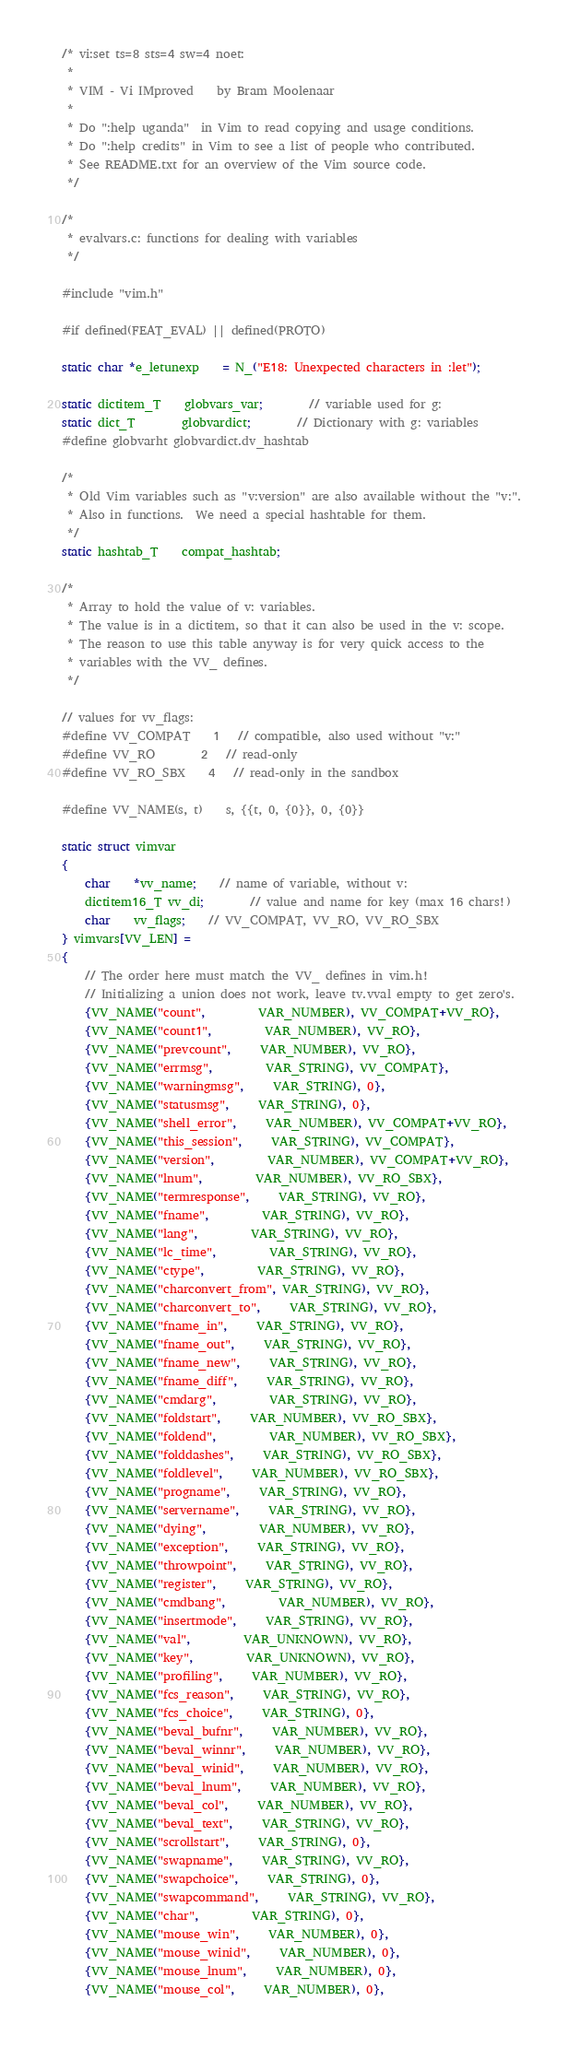Convert code to text. <code><loc_0><loc_0><loc_500><loc_500><_C_>/* vi:set ts=8 sts=4 sw=4 noet:
 *
 * VIM - Vi IMproved	by Bram Moolenaar
 *
 * Do ":help uganda"  in Vim to read copying and usage conditions.
 * Do ":help credits" in Vim to see a list of people who contributed.
 * See README.txt for an overview of the Vim source code.
 */

/*
 * evalvars.c: functions for dealing with variables
 */

#include "vim.h"

#if defined(FEAT_EVAL) || defined(PROTO)

static char *e_letunexp	= N_("E18: Unexpected characters in :let");

static dictitem_T	globvars_var;		// variable used for g:
static dict_T		globvardict;		// Dictionary with g: variables
#define globvarht globvardict.dv_hashtab

/*
 * Old Vim variables such as "v:version" are also available without the "v:".
 * Also in functions.  We need a special hashtable for them.
 */
static hashtab_T	compat_hashtab;

/*
 * Array to hold the value of v: variables.
 * The value is in a dictitem, so that it can also be used in the v: scope.
 * The reason to use this table anyway is for very quick access to the
 * variables with the VV_ defines.
 */

// values for vv_flags:
#define VV_COMPAT	1	// compatible, also used without "v:"
#define VV_RO		2	// read-only
#define VV_RO_SBX	4	// read-only in the sandbox

#define VV_NAME(s, t)	s, {{t, 0, {0}}, 0, {0}}

static struct vimvar
{
    char	*vv_name;	// name of variable, without v:
    dictitem16_T vv_di;		// value and name for key (max 16 chars!)
    char	vv_flags;	// VV_COMPAT, VV_RO, VV_RO_SBX
} vimvars[VV_LEN] =
{
    // The order here must match the VV_ defines in vim.h!
    // Initializing a union does not work, leave tv.vval empty to get zero's.
    {VV_NAME("count",		 VAR_NUMBER), VV_COMPAT+VV_RO},
    {VV_NAME("count1",		 VAR_NUMBER), VV_RO},
    {VV_NAME("prevcount",	 VAR_NUMBER), VV_RO},
    {VV_NAME("errmsg",		 VAR_STRING), VV_COMPAT},
    {VV_NAME("warningmsg",	 VAR_STRING), 0},
    {VV_NAME("statusmsg",	 VAR_STRING), 0},
    {VV_NAME("shell_error",	 VAR_NUMBER), VV_COMPAT+VV_RO},
    {VV_NAME("this_session",	 VAR_STRING), VV_COMPAT},
    {VV_NAME("version",		 VAR_NUMBER), VV_COMPAT+VV_RO},
    {VV_NAME("lnum",		 VAR_NUMBER), VV_RO_SBX},
    {VV_NAME("termresponse",	 VAR_STRING), VV_RO},
    {VV_NAME("fname",		 VAR_STRING), VV_RO},
    {VV_NAME("lang",		 VAR_STRING), VV_RO},
    {VV_NAME("lc_time",		 VAR_STRING), VV_RO},
    {VV_NAME("ctype",		 VAR_STRING), VV_RO},
    {VV_NAME("charconvert_from", VAR_STRING), VV_RO},
    {VV_NAME("charconvert_to",	 VAR_STRING), VV_RO},
    {VV_NAME("fname_in",	 VAR_STRING), VV_RO},
    {VV_NAME("fname_out",	 VAR_STRING), VV_RO},
    {VV_NAME("fname_new",	 VAR_STRING), VV_RO},
    {VV_NAME("fname_diff",	 VAR_STRING), VV_RO},
    {VV_NAME("cmdarg",		 VAR_STRING), VV_RO},
    {VV_NAME("foldstart",	 VAR_NUMBER), VV_RO_SBX},
    {VV_NAME("foldend",		 VAR_NUMBER), VV_RO_SBX},
    {VV_NAME("folddashes",	 VAR_STRING), VV_RO_SBX},
    {VV_NAME("foldlevel",	 VAR_NUMBER), VV_RO_SBX},
    {VV_NAME("progname",	 VAR_STRING), VV_RO},
    {VV_NAME("servername",	 VAR_STRING), VV_RO},
    {VV_NAME("dying",		 VAR_NUMBER), VV_RO},
    {VV_NAME("exception",	 VAR_STRING), VV_RO},
    {VV_NAME("throwpoint",	 VAR_STRING), VV_RO},
    {VV_NAME("register",	 VAR_STRING), VV_RO},
    {VV_NAME("cmdbang",		 VAR_NUMBER), VV_RO},
    {VV_NAME("insertmode",	 VAR_STRING), VV_RO},
    {VV_NAME("val",		 VAR_UNKNOWN), VV_RO},
    {VV_NAME("key",		 VAR_UNKNOWN), VV_RO},
    {VV_NAME("profiling",	 VAR_NUMBER), VV_RO},
    {VV_NAME("fcs_reason",	 VAR_STRING), VV_RO},
    {VV_NAME("fcs_choice",	 VAR_STRING), 0},
    {VV_NAME("beval_bufnr",	 VAR_NUMBER), VV_RO},
    {VV_NAME("beval_winnr",	 VAR_NUMBER), VV_RO},
    {VV_NAME("beval_winid",	 VAR_NUMBER), VV_RO},
    {VV_NAME("beval_lnum",	 VAR_NUMBER), VV_RO},
    {VV_NAME("beval_col",	 VAR_NUMBER), VV_RO},
    {VV_NAME("beval_text",	 VAR_STRING), VV_RO},
    {VV_NAME("scrollstart",	 VAR_STRING), 0},
    {VV_NAME("swapname",	 VAR_STRING), VV_RO},
    {VV_NAME("swapchoice",	 VAR_STRING), 0},
    {VV_NAME("swapcommand",	 VAR_STRING), VV_RO},
    {VV_NAME("char",		 VAR_STRING), 0},
    {VV_NAME("mouse_win",	 VAR_NUMBER), 0},
    {VV_NAME("mouse_winid",	 VAR_NUMBER), 0},
    {VV_NAME("mouse_lnum",	 VAR_NUMBER), 0},
    {VV_NAME("mouse_col",	 VAR_NUMBER), 0},</code> 